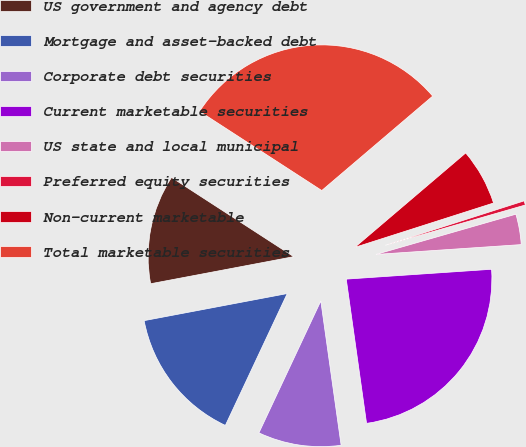<chart> <loc_0><loc_0><loc_500><loc_500><pie_chart><fcel>US government and agency debt<fcel>Mortgage and asset-backed debt<fcel>Corporate debt securities<fcel>Current marketable securities<fcel>US state and local municipal<fcel>Preferred equity securities<fcel>Non-current marketable<fcel>Total marketable securities<nl><fcel>12.13%<fcel>15.04%<fcel>9.21%<fcel>23.85%<fcel>3.38%<fcel>0.47%<fcel>6.3%<fcel>29.62%<nl></chart> 